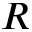<formula> <loc_0><loc_0><loc_500><loc_500>R</formula> 